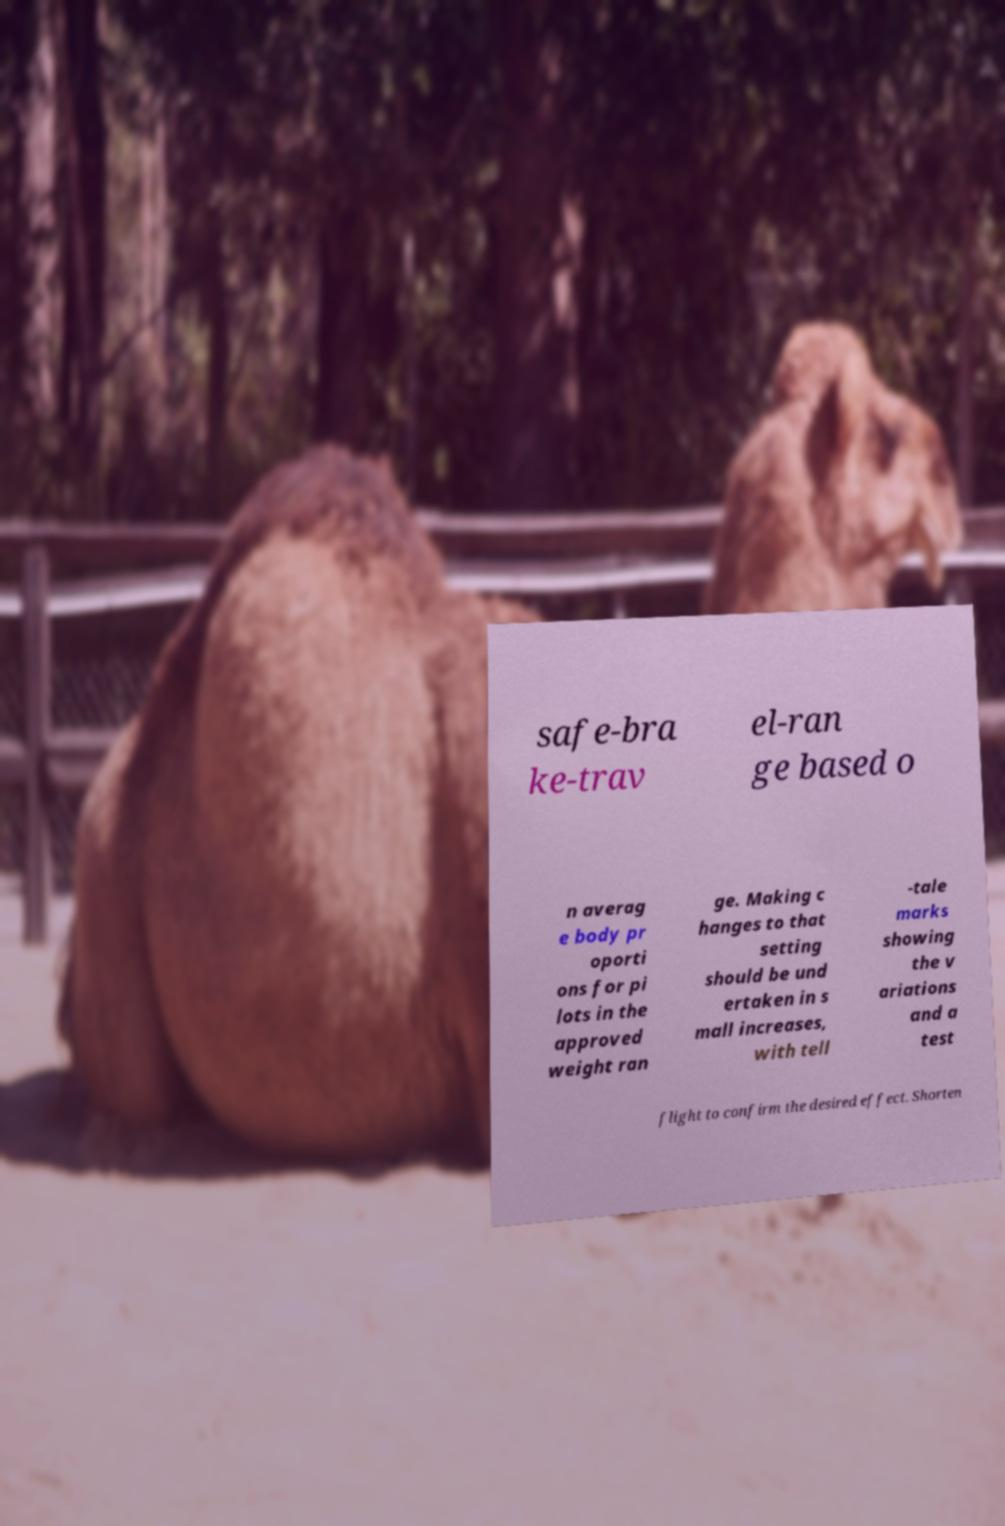What messages or text are displayed in this image? I need them in a readable, typed format. safe-bra ke-trav el-ran ge based o n averag e body pr oporti ons for pi lots in the approved weight ran ge. Making c hanges to that setting should be und ertaken in s mall increases, with tell -tale marks showing the v ariations and a test flight to confirm the desired effect. Shorten 